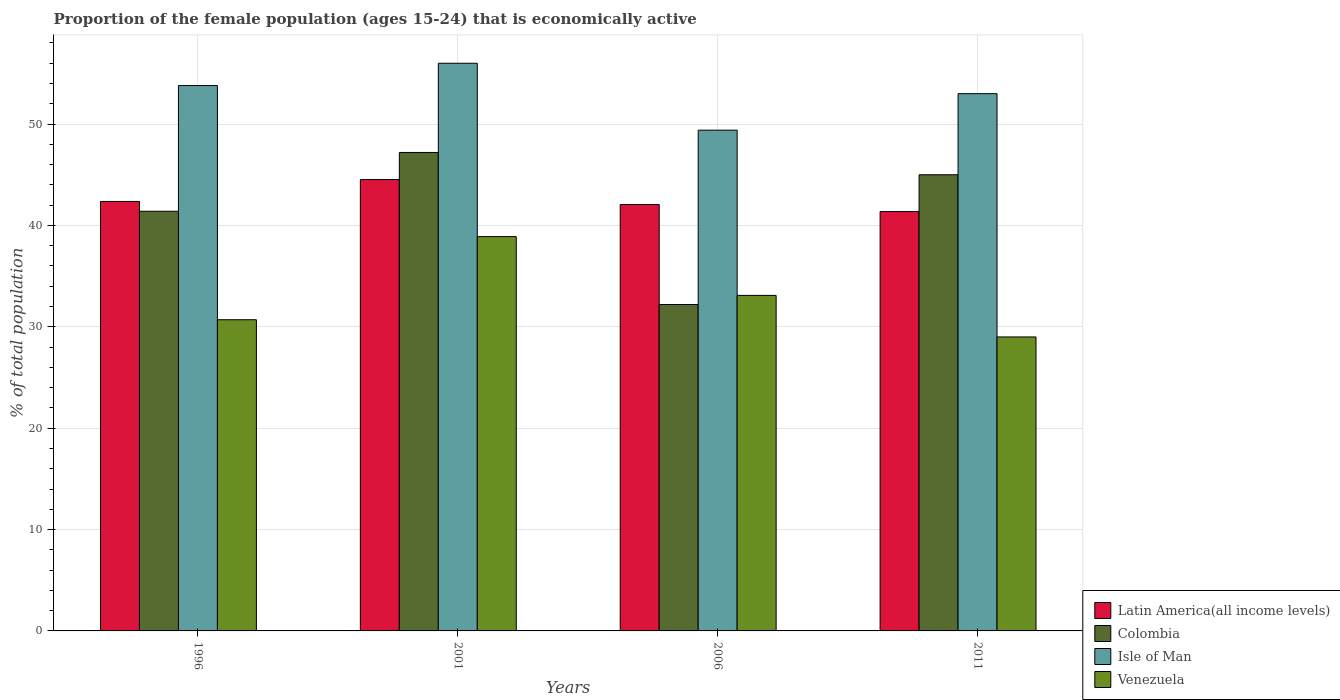How many different coloured bars are there?
Give a very brief answer. 4. How many groups of bars are there?
Your answer should be very brief. 4. Are the number of bars per tick equal to the number of legend labels?
Your answer should be compact. Yes. Are the number of bars on each tick of the X-axis equal?
Offer a terse response. Yes. How many bars are there on the 1st tick from the left?
Make the answer very short. 4. What is the label of the 2nd group of bars from the left?
Give a very brief answer. 2001. What is the proportion of the female population that is economically active in Isle of Man in 2001?
Provide a short and direct response. 56. Across all years, what is the maximum proportion of the female population that is economically active in Latin America(all income levels)?
Provide a succinct answer. 44.53. What is the total proportion of the female population that is economically active in Venezuela in the graph?
Your answer should be compact. 131.7. What is the difference between the proportion of the female population that is economically active in Isle of Man in 2006 and that in 2011?
Give a very brief answer. -3.6. What is the difference between the proportion of the female population that is economically active in Latin America(all income levels) in 2011 and the proportion of the female population that is economically active in Colombia in 2001?
Keep it short and to the point. -5.83. What is the average proportion of the female population that is economically active in Colombia per year?
Make the answer very short. 41.45. In the year 1996, what is the difference between the proportion of the female population that is economically active in Latin America(all income levels) and proportion of the female population that is economically active in Venezuela?
Give a very brief answer. 11.67. In how many years, is the proportion of the female population that is economically active in Colombia greater than 56 %?
Offer a terse response. 0. What is the ratio of the proportion of the female population that is economically active in Latin America(all income levels) in 1996 to that in 2011?
Give a very brief answer. 1.02. Is the proportion of the female population that is economically active in Latin America(all income levels) in 2006 less than that in 2011?
Ensure brevity in your answer.  No. Is the difference between the proportion of the female population that is economically active in Latin America(all income levels) in 2006 and 2011 greater than the difference between the proportion of the female population that is economically active in Venezuela in 2006 and 2011?
Offer a very short reply. No. What is the difference between the highest and the second highest proportion of the female population that is economically active in Latin America(all income levels)?
Ensure brevity in your answer.  2.16. In how many years, is the proportion of the female population that is economically active in Venezuela greater than the average proportion of the female population that is economically active in Venezuela taken over all years?
Your answer should be compact. 2. Is it the case that in every year, the sum of the proportion of the female population that is economically active in Colombia and proportion of the female population that is economically active in Isle of Man is greater than the sum of proportion of the female population that is economically active in Latin America(all income levels) and proportion of the female population that is economically active in Venezuela?
Offer a very short reply. Yes. What does the 3rd bar from the left in 2011 represents?
Offer a terse response. Isle of Man. Is it the case that in every year, the sum of the proportion of the female population that is economically active in Venezuela and proportion of the female population that is economically active in Latin America(all income levels) is greater than the proportion of the female population that is economically active in Isle of Man?
Your answer should be very brief. Yes. Are all the bars in the graph horizontal?
Provide a short and direct response. No. Are the values on the major ticks of Y-axis written in scientific E-notation?
Make the answer very short. No. How many legend labels are there?
Offer a very short reply. 4. How are the legend labels stacked?
Make the answer very short. Vertical. What is the title of the graph?
Offer a terse response. Proportion of the female population (ages 15-24) that is economically active. What is the label or title of the Y-axis?
Your answer should be very brief. % of total population. What is the % of total population of Latin America(all income levels) in 1996?
Make the answer very short. 42.37. What is the % of total population of Colombia in 1996?
Your answer should be very brief. 41.4. What is the % of total population in Isle of Man in 1996?
Make the answer very short. 53.8. What is the % of total population in Venezuela in 1996?
Provide a short and direct response. 30.7. What is the % of total population of Latin America(all income levels) in 2001?
Provide a succinct answer. 44.53. What is the % of total population in Colombia in 2001?
Your answer should be very brief. 47.2. What is the % of total population in Venezuela in 2001?
Offer a very short reply. 38.9. What is the % of total population of Latin America(all income levels) in 2006?
Give a very brief answer. 42.06. What is the % of total population in Colombia in 2006?
Keep it short and to the point. 32.2. What is the % of total population in Isle of Man in 2006?
Provide a short and direct response. 49.4. What is the % of total population of Venezuela in 2006?
Offer a terse response. 33.1. What is the % of total population of Latin America(all income levels) in 2011?
Give a very brief answer. 41.37. What is the % of total population of Colombia in 2011?
Ensure brevity in your answer.  45. What is the % of total population in Venezuela in 2011?
Give a very brief answer. 29. Across all years, what is the maximum % of total population of Latin America(all income levels)?
Offer a very short reply. 44.53. Across all years, what is the maximum % of total population of Colombia?
Your answer should be very brief. 47.2. Across all years, what is the maximum % of total population of Isle of Man?
Give a very brief answer. 56. Across all years, what is the maximum % of total population in Venezuela?
Keep it short and to the point. 38.9. Across all years, what is the minimum % of total population in Latin America(all income levels)?
Give a very brief answer. 41.37. Across all years, what is the minimum % of total population in Colombia?
Give a very brief answer. 32.2. Across all years, what is the minimum % of total population in Isle of Man?
Keep it short and to the point. 49.4. What is the total % of total population of Latin America(all income levels) in the graph?
Make the answer very short. 170.33. What is the total % of total population in Colombia in the graph?
Make the answer very short. 165.8. What is the total % of total population of Isle of Man in the graph?
Your answer should be very brief. 212.2. What is the total % of total population of Venezuela in the graph?
Your response must be concise. 131.7. What is the difference between the % of total population of Latin America(all income levels) in 1996 and that in 2001?
Ensure brevity in your answer.  -2.16. What is the difference between the % of total population of Latin America(all income levels) in 1996 and that in 2006?
Make the answer very short. 0.3. What is the difference between the % of total population of Colombia in 1996 and that in 2006?
Give a very brief answer. 9.2. What is the difference between the % of total population in Venezuela in 1996 and that in 2006?
Offer a very short reply. -2.4. What is the difference between the % of total population in Latin America(all income levels) in 1996 and that in 2011?
Give a very brief answer. 1. What is the difference between the % of total population in Isle of Man in 1996 and that in 2011?
Your response must be concise. 0.8. What is the difference between the % of total population in Venezuela in 1996 and that in 2011?
Ensure brevity in your answer.  1.7. What is the difference between the % of total population of Latin America(all income levels) in 2001 and that in 2006?
Provide a short and direct response. 2.46. What is the difference between the % of total population in Latin America(all income levels) in 2001 and that in 2011?
Your answer should be compact. 3.16. What is the difference between the % of total population in Isle of Man in 2001 and that in 2011?
Ensure brevity in your answer.  3. What is the difference between the % of total population of Latin America(all income levels) in 2006 and that in 2011?
Provide a short and direct response. 0.69. What is the difference between the % of total population in Isle of Man in 2006 and that in 2011?
Offer a very short reply. -3.6. What is the difference between the % of total population in Latin America(all income levels) in 1996 and the % of total population in Colombia in 2001?
Your answer should be very brief. -4.83. What is the difference between the % of total population of Latin America(all income levels) in 1996 and the % of total population of Isle of Man in 2001?
Make the answer very short. -13.63. What is the difference between the % of total population in Latin America(all income levels) in 1996 and the % of total population in Venezuela in 2001?
Keep it short and to the point. 3.47. What is the difference between the % of total population of Colombia in 1996 and the % of total population of Isle of Man in 2001?
Offer a terse response. -14.6. What is the difference between the % of total population of Colombia in 1996 and the % of total population of Venezuela in 2001?
Keep it short and to the point. 2.5. What is the difference between the % of total population in Isle of Man in 1996 and the % of total population in Venezuela in 2001?
Your response must be concise. 14.9. What is the difference between the % of total population in Latin America(all income levels) in 1996 and the % of total population in Colombia in 2006?
Ensure brevity in your answer.  10.17. What is the difference between the % of total population of Latin America(all income levels) in 1996 and the % of total population of Isle of Man in 2006?
Your answer should be compact. -7.03. What is the difference between the % of total population in Latin America(all income levels) in 1996 and the % of total population in Venezuela in 2006?
Provide a succinct answer. 9.27. What is the difference between the % of total population of Isle of Man in 1996 and the % of total population of Venezuela in 2006?
Offer a terse response. 20.7. What is the difference between the % of total population of Latin America(all income levels) in 1996 and the % of total population of Colombia in 2011?
Offer a very short reply. -2.63. What is the difference between the % of total population in Latin America(all income levels) in 1996 and the % of total population in Isle of Man in 2011?
Offer a very short reply. -10.63. What is the difference between the % of total population of Latin America(all income levels) in 1996 and the % of total population of Venezuela in 2011?
Your answer should be compact. 13.37. What is the difference between the % of total population of Colombia in 1996 and the % of total population of Venezuela in 2011?
Provide a succinct answer. 12.4. What is the difference between the % of total population of Isle of Man in 1996 and the % of total population of Venezuela in 2011?
Keep it short and to the point. 24.8. What is the difference between the % of total population of Latin America(all income levels) in 2001 and the % of total population of Colombia in 2006?
Your answer should be compact. 12.33. What is the difference between the % of total population of Latin America(all income levels) in 2001 and the % of total population of Isle of Man in 2006?
Offer a very short reply. -4.87. What is the difference between the % of total population of Latin America(all income levels) in 2001 and the % of total population of Venezuela in 2006?
Your response must be concise. 11.43. What is the difference between the % of total population in Colombia in 2001 and the % of total population in Isle of Man in 2006?
Provide a succinct answer. -2.2. What is the difference between the % of total population in Colombia in 2001 and the % of total population in Venezuela in 2006?
Your answer should be compact. 14.1. What is the difference between the % of total population of Isle of Man in 2001 and the % of total population of Venezuela in 2006?
Your answer should be compact. 22.9. What is the difference between the % of total population of Latin America(all income levels) in 2001 and the % of total population of Colombia in 2011?
Offer a very short reply. -0.47. What is the difference between the % of total population of Latin America(all income levels) in 2001 and the % of total population of Isle of Man in 2011?
Keep it short and to the point. -8.47. What is the difference between the % of total population of Latin America(all income levels) in 2001 and the % of total population of Venezuela in 2011?
Provide a short and direct response. 15.53. What is the difference between the % of total population of Colombia in 2001 and the % of total population of Isle of Man in 2011?
Your answer should be very brief. -5.8. What is the difference between the % of total population of Colombia in 2001 and the % of total population of Venezuela in 2011?
Provide a succinct answer. 18.2. What is the difference between the % of total population of Latin America(all income levels) in 2006 and the % of total population of Colombia in 2011?
Ensure brevity in your answer.  -2.94. What is the difference between the % of total population of Latin America(all income levels) in 2006 and the % of total population of Isle of Man in 2011?
Provide a succinct answer. -10.94. What is the difference between the % of total population in Latin America(all income levels) in 2006 and the % of total population in Venezuela in 2011?
Give a very brief answer. 13.06. What is the difference between the % of total population of Colombia in 2006 and the % of total population of Isle of Man in 2011?
Make the answer very short. -20.8. What is the difference between the % of total population in Colombia in 2006 and the % of total population in Venezuela in 2011?
Your response must be concise. 3.2. What is the difference between the % of total population of Isle of Man in 2006 and the % of total population of Venezuela in 2011?
Provide a short and direct response. 20.4. What is the average % of total population of Latin America(all income levels) per year?
Your answer should be very brief. 42.58. What is the average % of total population in Colombia per year?
Keep it short and to the point. 41.45. What is the average % of total population in Isle of Man per year?
Provide a short and direct response. 53.05. What is the average % of total population in Venezuela per year?
Make the answer very short. 32.92. In the year 1996, what is the difference between the % of total population in Latin America(all income levels) and % of total population in Colombia?
Ensure brevity in your answer.  0.97. In the year 1996, what is the difference between the % of total population of Latin America(all income levels) and % of total population of Isle of Man?
Provide a short and direct response. -11.43. In the year 1996, what is the difference between the % of total population of Latin America(all income levels) and % of total population of Venezuela?
Your answer should be compact. 11.67. In the year 1996, what is the difference between the % of total population of Colombia and % of total population of Isle of Man?
Your response must be concise. -12.4. In the year 1996, what is the difference between the % of total population in Colombia and % of total population in Venezuela?
Give a very brief answer. 10.7. In the year 1996, what is the difference between the % of total population in Isle of Man and % of total population in Venezuela?
Your response must be concise. 23.1. In the year 2001, what is the difference between the % of total population of Latin America(all income levels) and % of total population of Colombia?
Give a very brief answer. -2.67. In the year 2001, what is the difference between the % of total population in Latin America(all income levels) and % of total population in Isle of Man?
Provide a short and direct response. -11.47. In the year 2001, what is the difference between the % of total population of Latin America(all income levels) and % of total population of Venezuela?
Keep it short and to the point. 5.63. In the year 2001, what is the difference between the % of total population in Colombia and % of total population in Isle of Man?
Provide a succinct answer. -8.8. In the year 2001, what is the difference between the % of total population in Colombia and % of total population in Venezuela?
Offer a very short reply. 8.3. In the year 2001, what is the difference between the % of total population of Isle of Man and % of total population of Venezuela?
Your response must be concise. 17.1. In the year 2006, what is the difference between the % of total population of Latin America(all income levels) and % of total population of Colombia?
Keep it short and to the point. 9.86. In the year 2006, what is the difference between the % of total population in Latin America(all income levels) and % of total population in Isle of Man?
Make the answer very short. -7.34. In the year 2006, what is the difference between the % of total population in Latin America(all income levels) and % of total population in Venezuela?
Ensure brevity in your answer.  8.96. In the year 2006, what is the difference between the % of total population in Colombia and % of total population in Isle of Man?
Your answer should be very brief. -17.2. In the year 2011, what is the difference between the % of total population of Latin America(all income levels) and % of total population of Colombia?
Your answer should be very brief. -3.63. In the year 2011, what is the difference between the % of total population of Latin America(all income levels) and % of total population of Isle of Man?
Provide a short and direct response. -11.63. In the year 2011, what is the difference between the % of total population in Latin America(all income levels) and % of total population in Venezuela?
Provide a short and direct response. 12.37. What is the ratio of the % of total population of Latin America(all income levels) in 1996 to that in 2001?
Provide a succinct answer. 0.95. What is the ratio of the % of total population of Colombia in 1996 to that in 2001?
Your response must be concise. 0.88. What is the ratio of the % of total population of Isle of Man in 1996 to that in 2001?
Make the answer very short. 0.96. What is the ratio of the % of total population of Venezuela in 1996 to that in 2001?
Make the answer very short. 0.79. What is the ratio of the % of total population of Latin America(all income levels) in 1996 to that in 2006?
Offer a very short reply. 1.01. What is the ratio of the % of total population of Colombia in 1996 to that in 2006?
Offer a terse response. 1.29. What is the ratio of the % of total population of Isle of Man in 1996 to that in 2006?
Offer a very short reply. 1.09. What is the ratio of the % of total population in Venezuela in 1996 to that in 2006?
Make the answer very short. 0.93. What is the ratio of the % of total population of Latin America(all income levels) in 1996 to that in 2011?
Provide a succinct answer. 1.02. What is the ratio of the % of total population of Colombia in 1996 to that in 2011?
Ensure brevity in your answer.  0.92. What is the ratio of the % of total population in Isle of Man in 1996 to that in 2011?
Your answer should be compact. 1.02. What is the ratio of the % of total population of Venezuela in 1996 to that in 2011?
Your answer should be compact. 1.06. What is the ratio of the % of total population of Latin America(all income levels) in 2001 to that in 2006?
Your answer should be very brief. 1.06. What is the ratio of the % of total population of Colombia in 2001 to that in 2006?
Your response must be concise. 1.47. What is the ratio of the % of total population in Isle of Man in 2001 to that in 2006?
Provide a short and direct response. 1.13. What is the ratio of the % of total population in Venezuela in 2001 to that in 2006?
Ensure brevity in your answer.  1.18. What is the ratio of the % of total population in Latin America(all income levels) in 2001 to that in 2011?
Offer a terse response. 1.08. What is the ratio of the % of total population of Colombia in 2001 to that in 2011?
Make the answer very short. 1.05. What is the ratio of the % of total population of Isle of Man in 2001 to that in 2011?
Your response must be concise. 1.06. What is the ratio of the % of total population of Venezuela in 2001 to that in 2011?
Make the answer very short. 1.34. What is the ratio of the % of total population in Latin America(all income levels) in 2006 to that in 2011?
Give a very brief answer. 1.02. What is the ratio of the % of total population of Colombia in 2006 to that in 2011?
Your response must be concise. 0.72. What is the ratio of the % of total population of Isle of Man in 2006 to that in 2011?
Your answer should be very brief. 0.93. What is the ratio of the % of total population of Venezuela in 2006 to that in 2011?
Your response must be concise. 1.14. What is the difference between the highest and the second highest % of total population in Latin America(all income levels)?
Make the answer very short. 2.16. What is the difference between the highest and the second highest % of total population in Colombia?
Your answer should be compact. 2.2. What is the difference between the highest and the second highest % of total population in Isle of Man?
Give a very brief answer. 2.2. What is the difference between the highest and the lowest % of total population of Latin America(all income levels)?
Your response must be concise. 3.16. What is the difference between the highest and the lowest % of total population in Colombia?
Provide a succinct answer. 15. What is the difference between the highest and the lowest % of total population in Venezuela?
Offer a terse response. 9.9. 